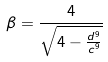<formula> <loc_0><loc_0><loc_500><loc_500>\beta = \frac { 4 } { \sqrt { 4 - \frac { d ^ { 9 } } { c ^ { 9 } } } }</formula> 